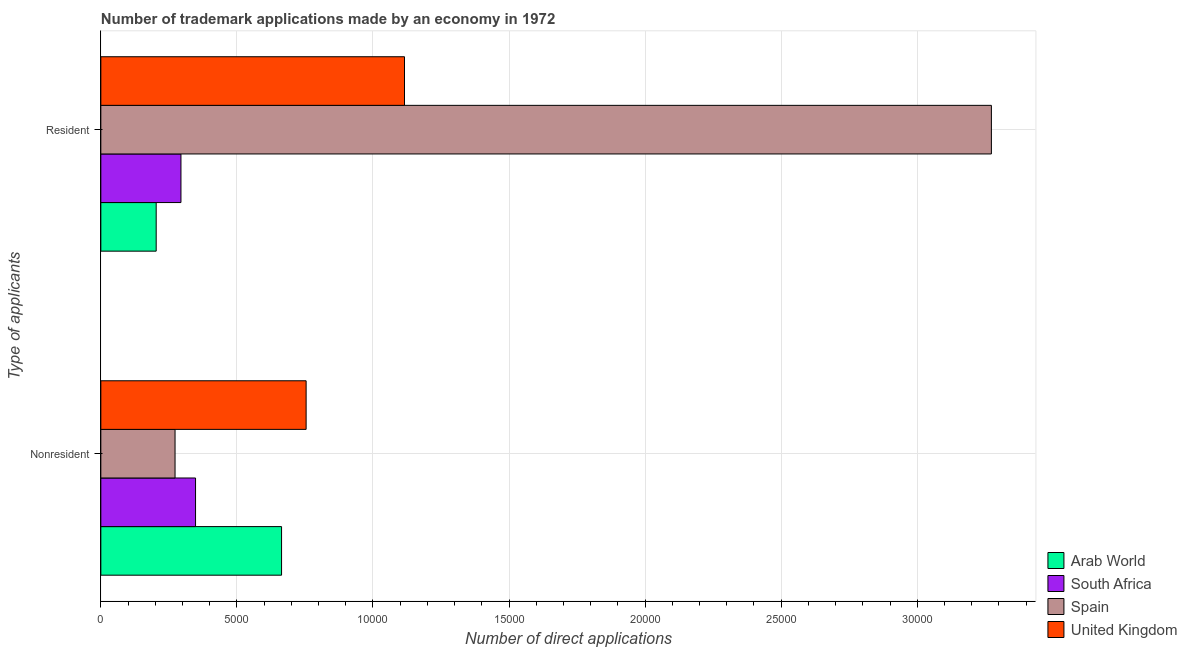How many groups of bars are there?
Give a very brief answer. 2. Are the number of bars per tick equal to the number of legend labels?
Give a very brief answer. Yes. How many bars are there on the 2nd tick from the bottom?
Ensure brevity in your answer.  4. What is the label of the 2nd group of bars from the top?
Your answer should be very brief. Nonresident. What is the number of trademark applications made by residents in Arab World?
Offer a very short reply. 2034. Across all countries, what is the maximum number of trademark applications made by non residents?
Ensure brevity in your answer.  7544. Across all countries, what is the minimum number of trademark applications made by residents?
Your answer should be very brief. 2034. In which country was the number of trademark applications made by non residents minimum?
Provide a succinct answer. Spain. What is the total number of trademark applications made by residents in the graph?
Your answer should be compact. 4.89e+04. What is the difference between the number of trademark applications made by residents in Spain and that in South Africa?
Offer a very short reply. 2.98e+04. What is the difference between the number of trademark applications made by non residents in Arab World and the number of trademark applications made by residents in Spain?
Provide a short and direct response. -2.61e+04. What is the average number of trademark applications made by non residents per country?
Provide a short and direct response. 5098. What is the difference between the number of trademark applications made by non residents and number of trademark applications made by residents in United Kingdom?
Your answer should be very brief. -3615. What is the ratio of the number of trademark applications made by residents in South Africa to that in Arab World?
Your answer should be very brief. 1.45. Is the number of trademark applications made by residents in Arab World less than that in Spain?
Provide a short and direct response. Yes. What does the 3rd bar from the top in Resident represents?
Keep it short and to the point. South Africa. What does the 2nd bar from the bottom in Nonresident represents?
Provide a short and direct response. South Africa. How many bars are there?
Provide a short and direct response. 8. Are the values on the major ticks of X-axis written in scientific E-notation?
Provide a short and direct response. No. Does the graph contain any zero values?
Provide a succinct answer. No. How are the legend labels stacked?
Your answer should be compact. Vertical. What is the title of the graph?
Keep it short and to the point. Number of trademark applications made by an economy in 1972. Does "Ireland" appear as one of the legend labels in the graph?
Keep it short and to the point. No. What is the label or title of the X-axis?
Your response must be concise. Number of direct applications. What is the label or title of the Y-axis?
Offer a terse response. Type of applicants. What is the Number of direct applications in Arab World in Nonresident?
Provide a succinct answer. 6641. What is the Number of direct applications in South Africa in Nonresident?
Your answer should be very brief. 3480. What is the Number of direct applications of Spain in Nonresident?
Provide a succinct answer. 2727. What is the Number of direct applications in United Kingdom in Nonresident?
Ensure brevity in your answer.  7544. What is the Number of direct applications in Arab World in Resident?
Provide a succinct answer. 2034. What is the Number of direct applications in South Africa in Resident?
Give a very brief answer. 2944. What is the Number of direct applications of Spain in Resident?
Offer a terse response. 3.27e+04. What is the Number of direct applications in United Kingdom in Resident?
Provide a succinct answer. 1.12e+04. Across all Type of applicants, what is the maximum Number of direct applications of Arab World?
Give a very brief answer. 6641. Across all Type of applicants, what is the maximum Number of direct applications of South Africa?
Provide a succinct answer. 3480. Across all Type of applicants, what is the maximum Number of direct applications of Spain?
Your response must be concise. 3.27e+04. Across all Type of applicants, what is the maximum Number of direct applications in United Kingdom?
Provide a succinct answer. 1.12e+04. Across all Type of applicants, what is the minimum Number of direct applications in Arab World?
Keep it short and to the point. 2034. Across all Type of applicants, what is the minimum Number of direct applications in South Africa?
Provide a succinct answer. 2944. Across all Type of applicants, what is the minimum Number of direct applications in Spain?
Offer a very short reply. 2727. Across all Type of applicants, what is the minimum Number of direct applications of United Kingdom?
Your response must be concise. 7544. What is the total Number of direct applications in Arab World in the graph?
Give a very brief answer. 8675. What is the total Number of direct applications in South Africa in the graph?
Offer a very short reply. 6424. What is the total Number of direct applications of Spain in the graph?
Provide a short and direct response. 3.55e+04. What is the total Number of direct applications of United Kingdom in the graph?
Offer a terse response. 1.87e+04. What is the difference between the Number of direct applications of Arab World in Nonresident and that in Resident?
Your response must be concise. 4607. What is the difference between the Number of direct applications in South Africa in Nonresident and that in Resident?
Your answer should be compact. 536. What is the difference between the Number of direct applications of Spain in Nonresident and that in Resident?
Keep it short and to the point. -3.00e+04. What is the difference between the Number of direct applications of United Kingdom in Nonresident and that in Resident?
Make the answer very short. -3615. What is the difference between the Number of direct applications of Arab World in Nonresident and the Number of direct applications of South Africa in Resident?
Provide a succinct answer. 3697. What is the difference between the Number of direct applications in Arab World in Nonresident and the Number of direct applications in Spain in Resident?
Provide a succinct answer. -2.61e+04. What is the difference between the Number of direct applications of Arab World in Nonresident and the Number of direct applications of United Kingdom in Resident?
Ensure brevity in your answer.  -4518. What is the difference between the Number of direct applications of South Africa in Nonresident and the Number of direct applications of Spain in Resident?
Provide a succinct answer. -2.92e+04. What is the difference between the Number of direct applications in South Africa in Nonresident and the Number of direct applications in United Kingdom in Resident?
Keep it short and to the point. -7679. What is the difference between the Number of direct applications of Spain in Nonresident and the Number of direct applications of United Kingdom in Resident?
Provide a succinct answer. -8432. What is the average Number of direct applications in Arab World per Type of applicants?
Keep it short and to the point. 4337.5. What is the average Number of direct applications of South Africa per Type of applicants?
Provide a succinct answer. 3212. What is the average Number of direct applications of Spain per Type of applicants?
Ensure brevity in your answer.  1.77e+04. What is the average Number of direct applications in United Kingdom per Type of applicants?
Offer a terse response. 9351.5. What is the difference between the Number of direct applications in Arab World and Number of direct applications in South Africa in Nonresident?
Make the answer very short. 3161. What is the difference between the Number of direct applications in Arab World and Number of direct applications in Spain in Nonresident?
Your answer should be compact. 3914. What is the difference between the Number of direct applications of Arab World and Number of direct applications of United Kingdom in Nonresident?
Provide a short and direct response. -903. What is the difference between the Number of direct applications of South Africa and Number of direct applications of Spain in Nonresident?
Provide a short and direct response. 753. What is the difference between the Number of direct applications of South Africa and Number of direct applications of United Kingdom in Nonresident?
Provide a succinct answer. -4064. What is the difference between the Number of direct applications of Spain and Number of direct applications of United Kingdom in Nonresident?
Provide a succinct answer. -4817. What is the difference between the Number of direct applications in Arab World and Number of direct applications in South Africa in Resident?
Offer a very short reply. -910. What is the difference between the Number of direct applications in Arab World and Number of direct applications in Spain in Resident?
Keep it short and to the point. -3.07e+04. What is the difference between the Number of direct applications of Arab World and Number of direct applications of United Kingdom in Resident?
Make the answer very short. -9125. What is the difference between the Number of direct applications of South Africa and Number of direct applications of Spain in Resident?
Give a very brief answer. -2.98e+04. What is the difference between the Number of direct applications in South Africa and Number of direct applications in United Kingdom in Resident?
Give a very brief answer. -8215. What is the difference between the Number of direct applications of Spain and Number of direct applications of United Kingdom in Resident?
Provide a short and direct response. 2.16e+04. What is the ratio of the Number of direct applications in Arab World in Nonresident to that in Resident?
Your answer should be very brief. 3.27. What is the ratio of the Number of direct applications in South Africa in Nonresident to that in Resident?
Offer a terse response. 1.18. What is the ratio of the Number of direct applications in Spain in Nonresident to that in Resident?
Ensure brevity in your answer.  0.08. What is the ratio of the Number of direct applications in United Kingdom in Nonresident to that in Resident?
Make the answer very short. 0.68. What is the difference between the highest and the second highest Number of direct applications of Arab World?
Make the answer very short. 4607. What is the difference between the highest and the second highest Number of direct applications in South Africa?
Give a very brief answer. 536. What is the difference between the highest and the second highest Number of direct applications of Spain?
Offer a terse response. 3.00e+04. What is the difference between the highest and the second highest Number of direct applications in United Kingdom?
Make the answer very short. 3615. What is the difference between the highest and the lowest Number of direct applications of Arab World?
Your response must be concise. 4607. What is the difference between the highest and the lowest Number of direct applications of South Africa?
Give a very brief answer. 536. What is the difference between the highest and the lowest Number of direct applications of Spain?
Make the answer very short. 3.00e+04. What is the difference between the highest and the lowest Number of direct applications in United Kingdom?
Your answer should be very brief. 3615. 